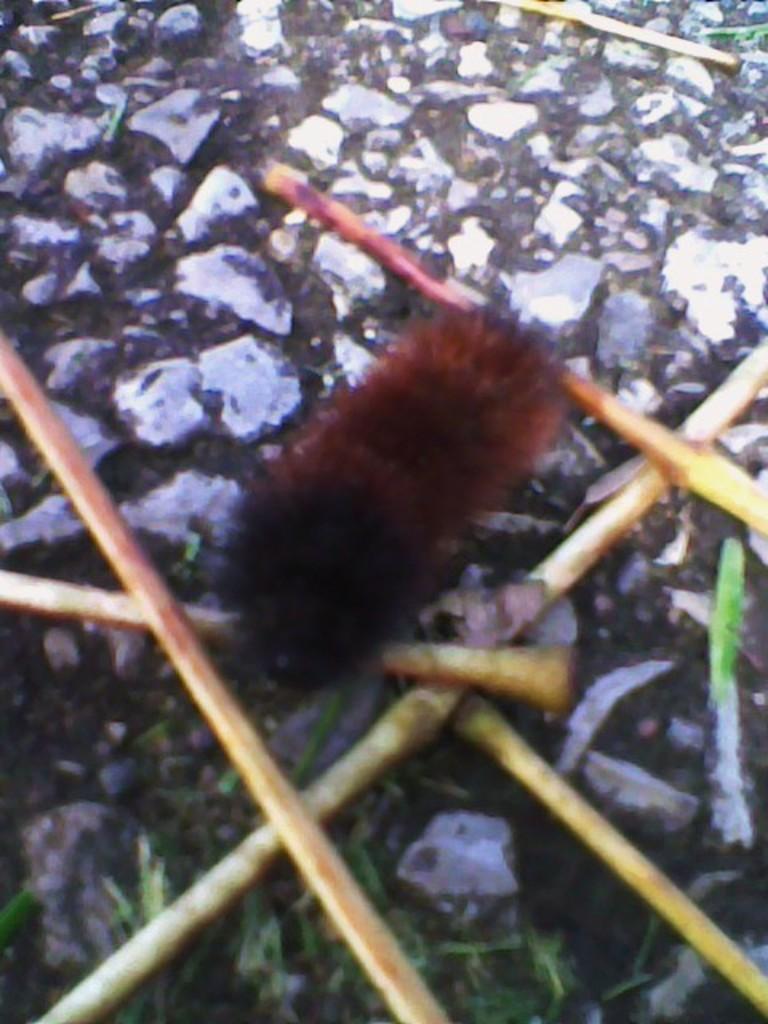Can you describe this image briefly? In this picture I can see insect on the surface 